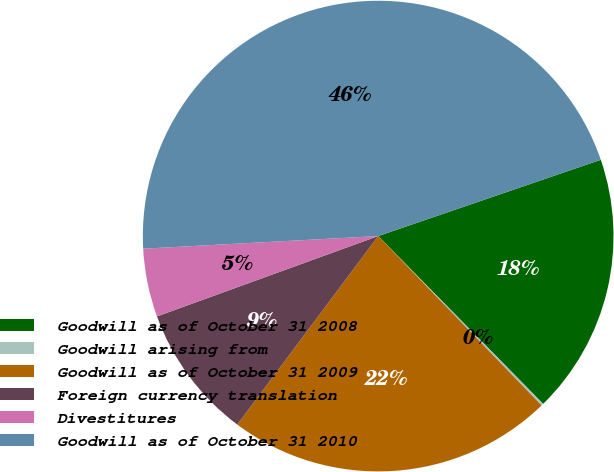<chart> <loc_0><loc_0><loc_500><loc_500><pie_chart><fcel>Goodwill as of October 31 2008<fcel>Goodwill arising from<fcel>Goodwill as of October 31 2009<fcel>Foreign currency translation<fcel>Divestitures<fcel>Goodwill as of October 31 2010<nl><fcel>17.89%<fcel>0.15%<fcel>22.43%<fcel>9.24%<fcel>4.69%<fcel>45.6%<nl></chart> 